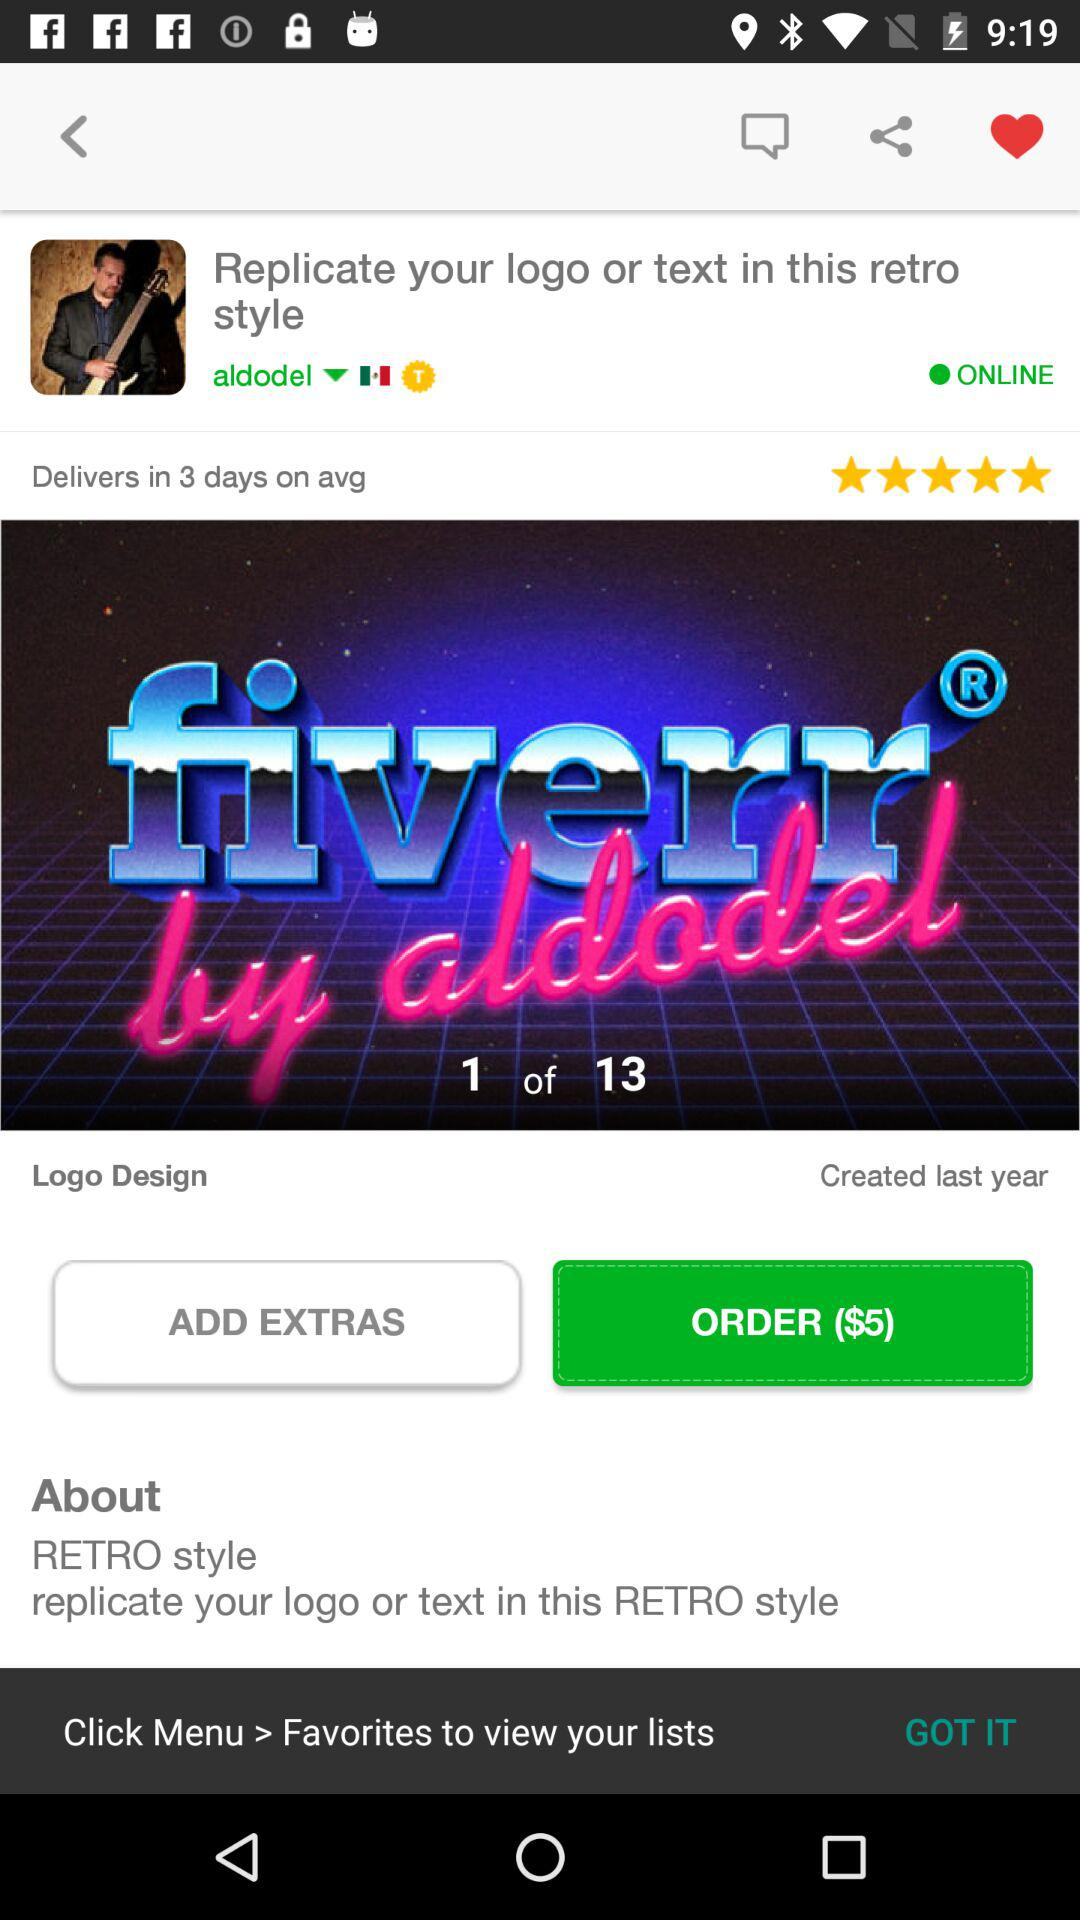When was the logo created? The logo was created last year. 